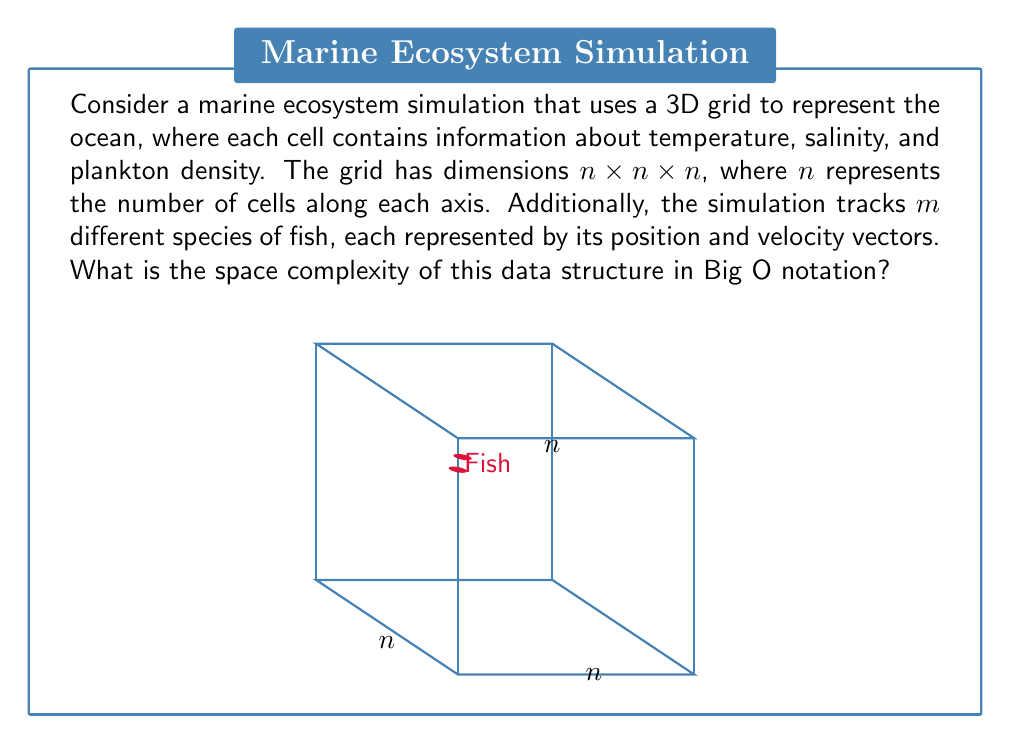Help me with this question. Let's break down the space complexity analysis step-by-step:

1. 3D Grid:
   - The grid has dimensions $n \times n \times n$
   - Each cell contains 3 pieces of information: temperature, salinity, and plankton density
   - Total space for the grid: $O(n^3)$

2. Fish Data:
   - There are $m$ species of fish
   - Each fish is represented by its position (3D vector) and velocity (3D vector)
   - Total space for fish data: $O(m)$

3. Combining the space requirements:
   - Total space = Space for grid + Space for fish
   - $O(n^3 + m)$

4. Simplifying the expression:
   - In most realistic simulations, the number of fish species ($m$) would be significantly smaller than the number of grid cells ($n^3$)
   - Therefore, $n^3$ dominates the space complexity

5. Final space complexity:
   - $O(n^3)$

This space complexity reflects the three-dimensional nature of the ocean environment, which is crucial for accurate marine ecosystem simulations. The cubic growth with respect to $n$ emphasizes the computational challenges faced when increasing the resolution of such simulations, a concern that would be familiar to someone with a background in oceanography and marine biology.
Answer: $O(n^3)$ 